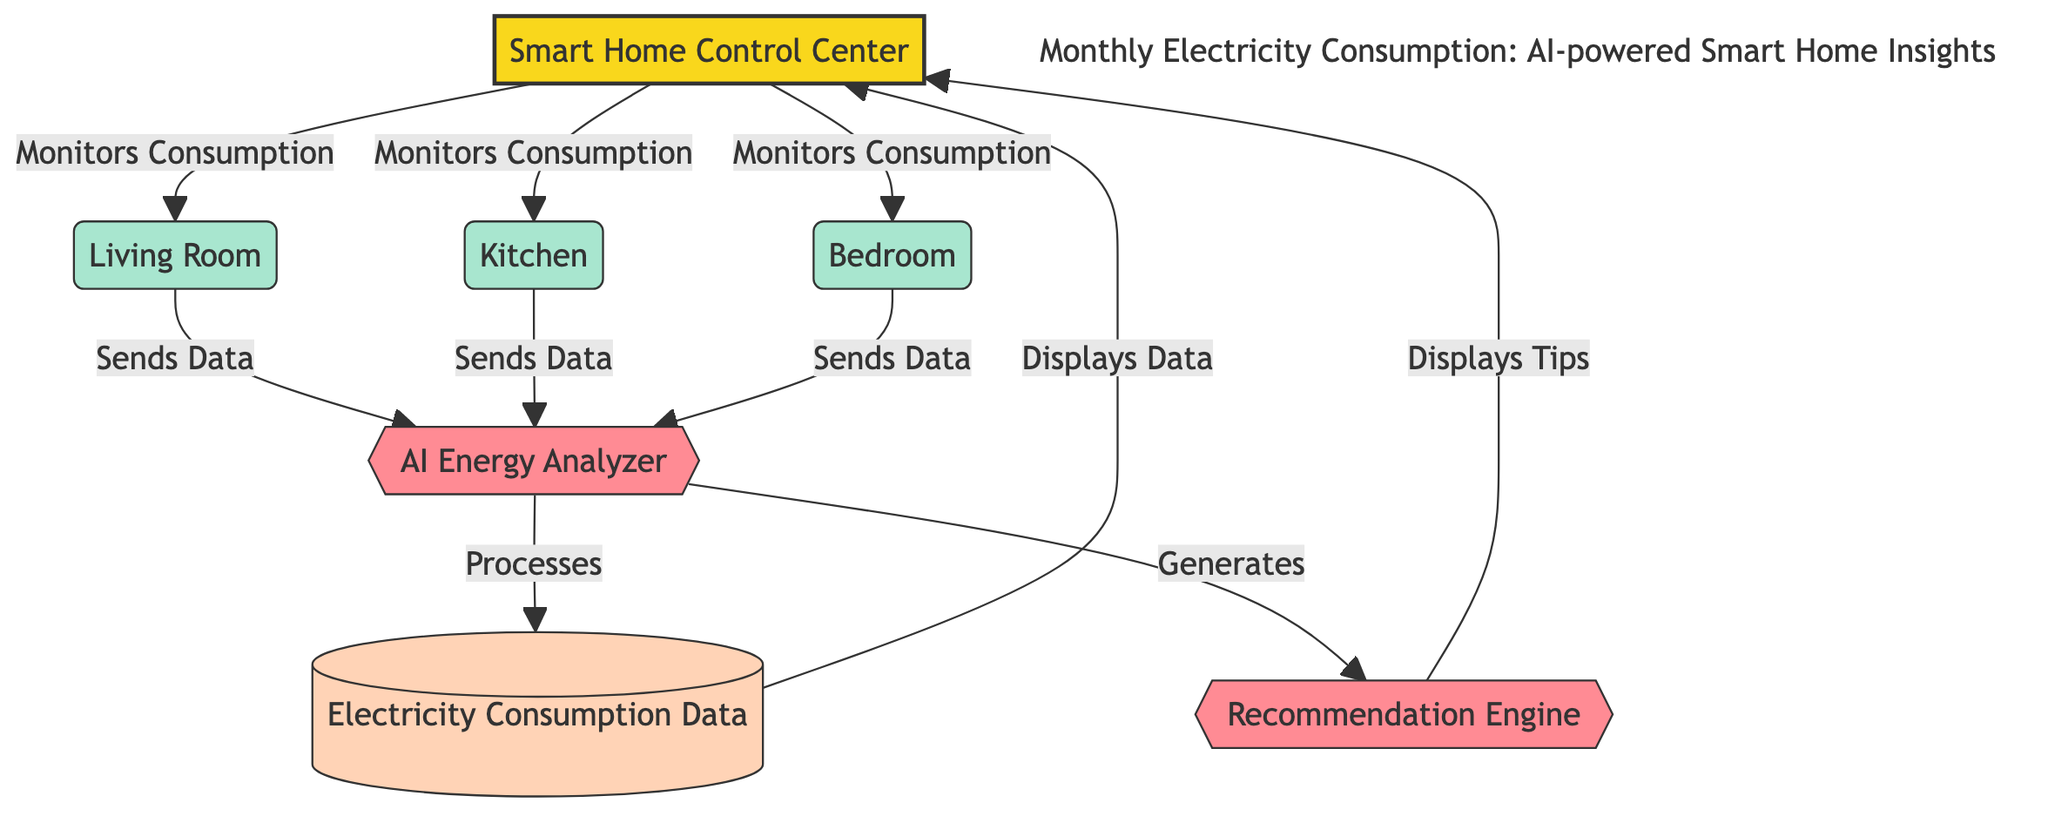What are the three rooms monitored by the Smart Home Control Center? The diagram shows three rooms connected to the Smart Home Control Center: the Living Room, Kitchen, and Bedroom. These are the nodes that directly receive monitoring from the center.
Answer: Living Room, Kitchen, Bedroom How many nodes are present in the diagram? The diagram includes a total of seven nodes: one central control node, three room nodes, one AI Energy Analyzer node, one Electricity Consumption Data node, and one Recommendation Engine node. Counting them gives us the total of seven.
Answer: Seven Which node displays tips? According to the diagram, the Recommendation Engine node is responsible for displaying tips. It connects to the Smart Home Control Center to share these recommendations.
Answer: Recommendation Engine What role does the AI Energy Analyzer play in the diagram? The AI Energy Analyzer processes the Electricity Consumption Data and generates recommendations, which it then passes back to the Smart Home Control Center for display. Its role encompasses analysis and generation of insights.
Answer: Processes and generates How does the Living Room node interact with the AI Energy Analyzer? The Living Room node sends data to the AI Energy Analyzer, which is represented by the direct edge connecting these two nodes in the diagram. This interaction is crucial for providing insights from the Electricity Consumption Data based on the Living Room's usage.
Answer: Sends Data What is the final output the Smart Home Control Center receives? The final output consists of both processed Electricity Consumption Data and tips from the Recommendation Engine. These are displayed back at the Smart Home Control Center, combining analysis and actionable suggestions.
Answer: Processed Data and Tips 